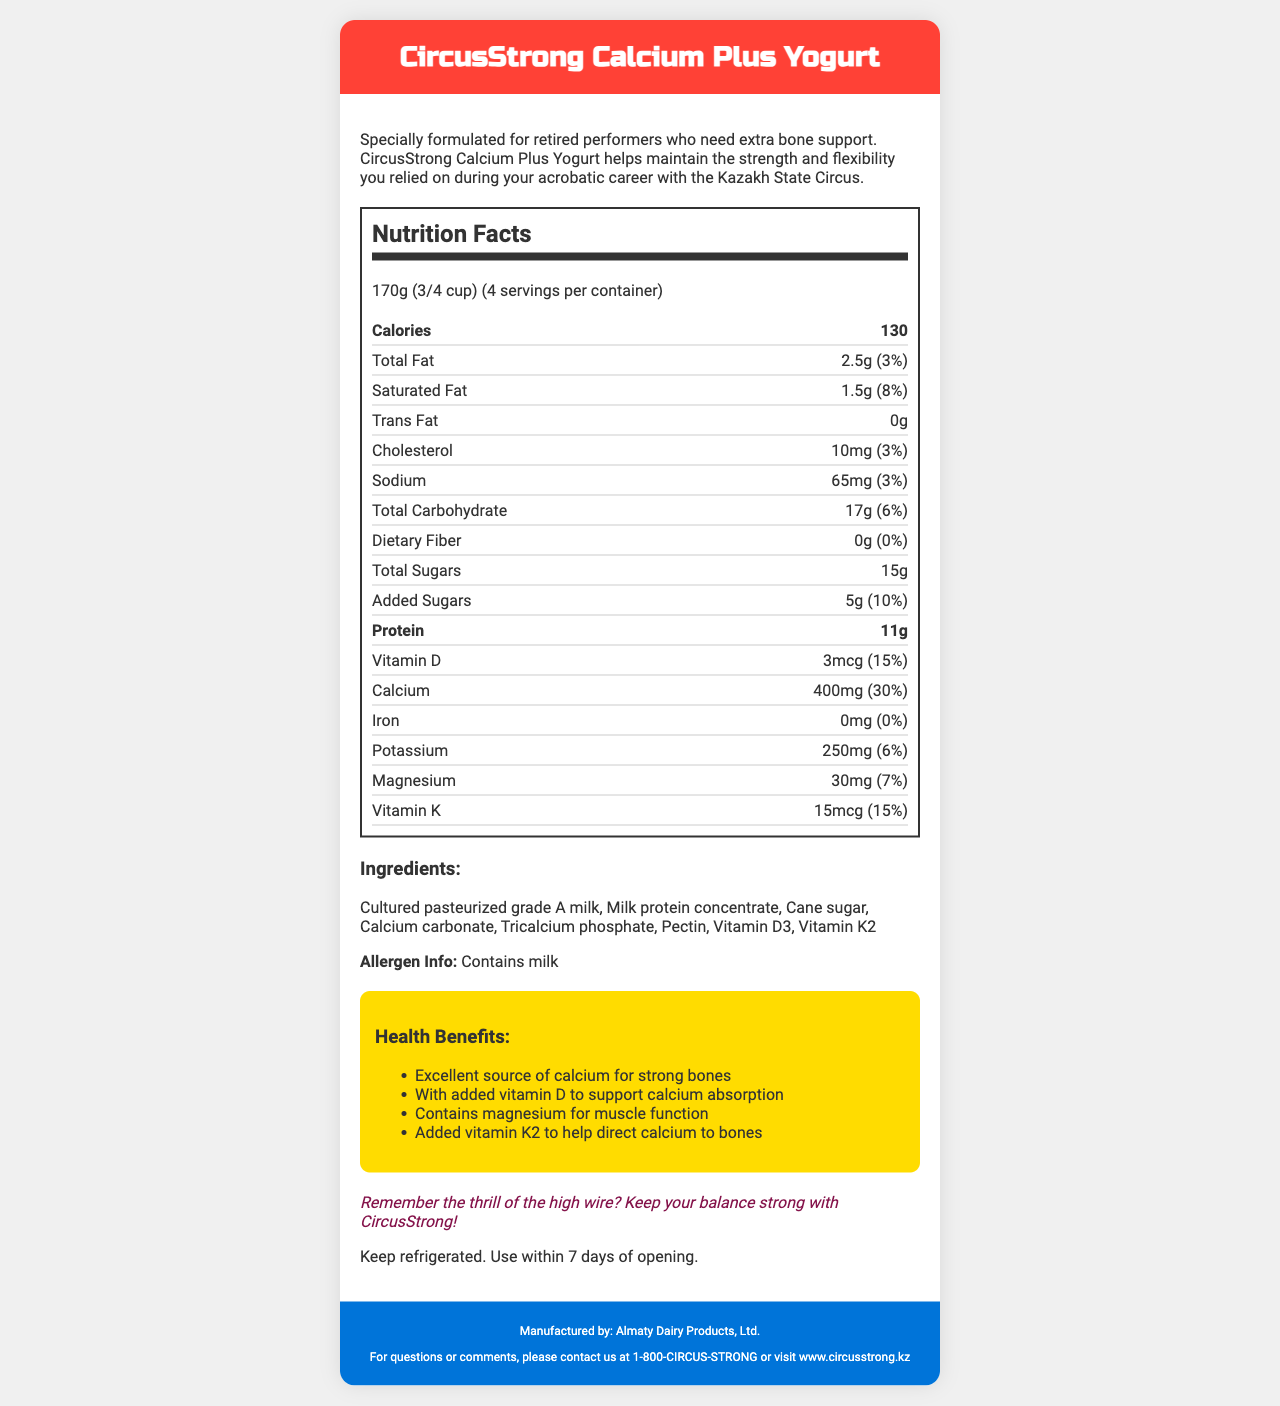what is the serving size for CircusStrong Calcium Plus Yogurt? The serving size is mentioned at the top of the nutrition facts label.
Answer: 170g (3/4 cup) how many calories are in one serving of CircusStrong Calcium Plus Yogurt? The calories per serving are listed right below the serving size.
Answer: 130 what percentage of daily calcium does one serving provide? The calcium amount and the percentage of daily value are provided in the nutrition facts section.
Answer: 30% what are the three main health benefits claimed for this product? These health benefits are listed under the "Health Benefits" section.
Answer: Excellent source of calcium for strong bones, With added vitamin D to support calcium absorption, Contains magnesium for muscle function how many grams of protein are in one serving? Protein content per serving is listed in the nutrition facts.
Answer: 11g which nutrient amounts to 15% of the daily value in one serving? A. Iron B. Vitamin D C. Vitamin K D. Potassium The nutrition facts section shows Vitamin K as having a daily value of 15%.
Answer: C. Vitamin K where should the product be stored after opening? Storage instructions mention that the product should be kept refrigerated and used within 7 days of opening.
Answer: Keep refrigerated who is the manufacturer of CircusStrong Calcium Plus Yogurt? The manufacturer's name is given at the bottom of the document under the contact information.
Answer: Almaty Dairy Products, Ltd. how many grams of total fat does one serving contain? The amount of total fat per serving is listed in the nutrition facts.
Answer: 2.5g what is the marketed slogan that connects the yogurt to the circus experience? The slogan is found in the circus nostalgia section of the document.
Answer: Remember the thrill of the high wire? Keep your balance strong with CircusStrong! how much sodium is present in one serving of CircusStrong Calcium Plus Yogurt? Sodium content per serving is listed in the nutrition facts.
Answer: 65mg in which city is the manufacturer's company located? The document provides the name of the manufacturer but doesn't specify the city.
Answer: Not enough information which ingredient is used to fortify the product with calcium? A. Milk protein concentrate B. Calcium carbonate C. Cane sugar D. Pectin The list of ingredients includes Calcium carbonate as one of the elements.
Answer: B. Calcium carbonate which daily values are not provided for any nutrient in the document? The document specifically mentions 0% daily value for Iron and Dietary Fiber, and 0g of Trans Fat without a daily value.
Answer: Iron, Dietary Fiber, Trans Fat is CircusStrong Calcium Plus Yogurt suitable for someone with a milk allergy? The allergen info explicitly states that the product contains milk.
Answer: No What is the main idea of the document? The document highlights the product's benefits, nutritional content, ingredients, and how it aids in bone health and muscle function for retired circus performers.
Answer: CircusStrong Calcium Plus Yogurt is a specially formulated dairy product for retired performers focusing on bone health and flexibility, packed with essential nutrients like calcium, vitamin D, magnesium, and vitamin K. what is the address of the manufacturer? The document does not provide the physical address of the manufacturer.
Answer: Not enough information 